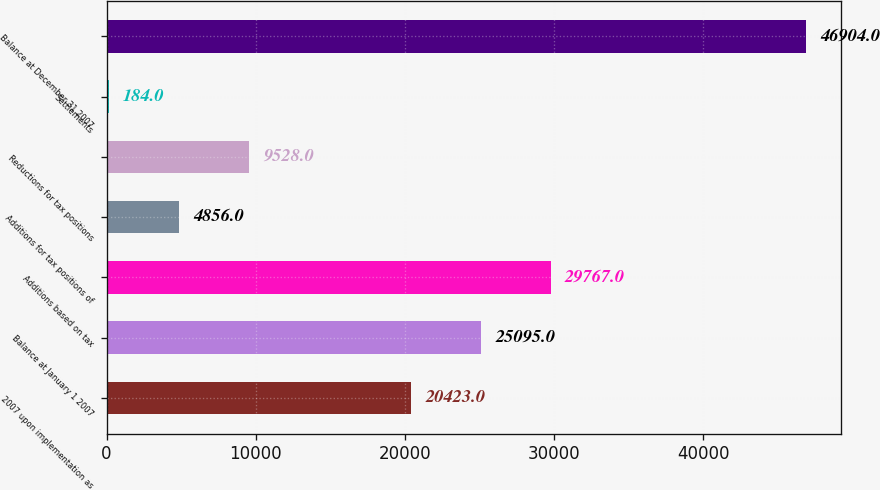Convert chart. <chart><loc_0><loc_0><loc_500><loc_500><bar_chart><fcel>2007 upon implementation as<fcel>Balance at January 1 2007<fcel>Additions based on tax<fcel>Additions for tax positions of<fcel>Reductions for tax positions<fcel>Settlements<fcel>Balance at December 31 2007<nl><fcel>20423<fcel>25095<fcel>29767<fcel>4856<fcel>9528<fcel>184<fcel>46904<nl></chart> 